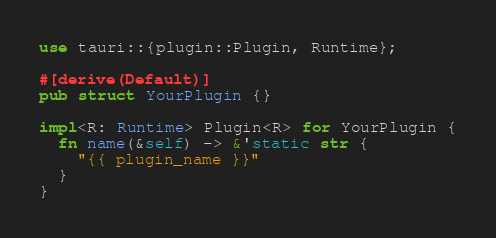Convert code to text. <code><loc_0><loc_0><loc_500><loc_500><_Rust_>use tauri::{plugin::Plugin, Runtime};

#[derive(Default)]
pub struct YourPlugin {}

impl<R: Runtime> Plugin<R> for YourPlugin {
  fn name(&self) -> &'static str {
    "{{ plugin_name }}"
  }
}
</code> 